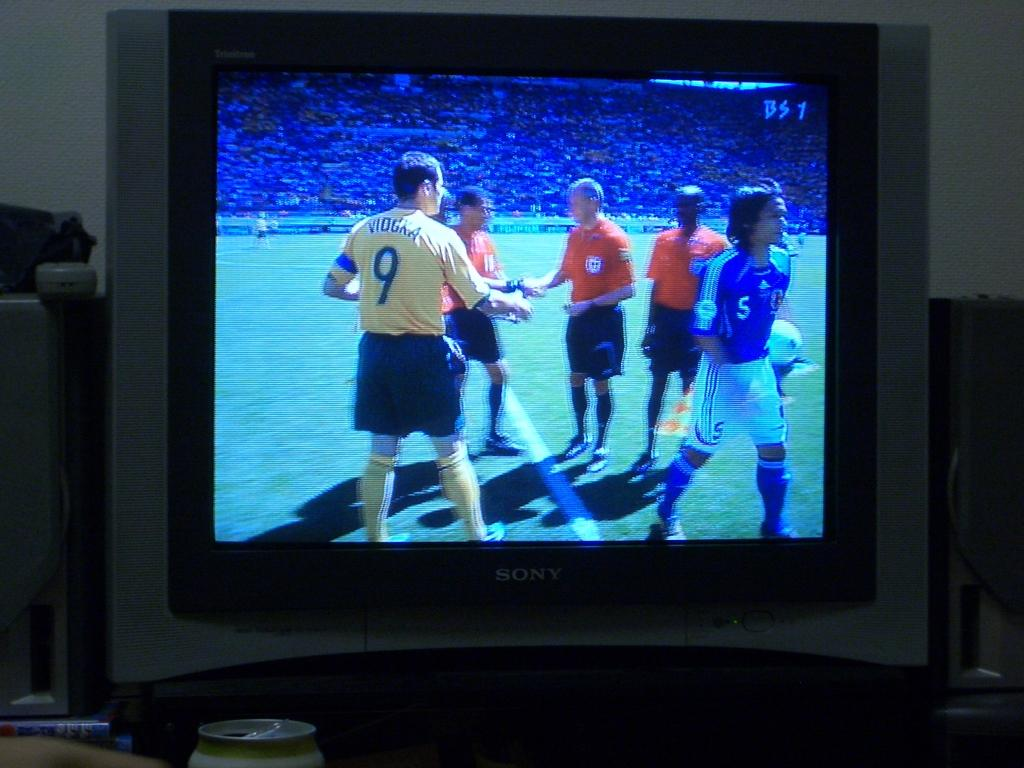Provide a one-sentence caption for the provided image. A picture on a TV that has a BS1 in the upper right corner. 